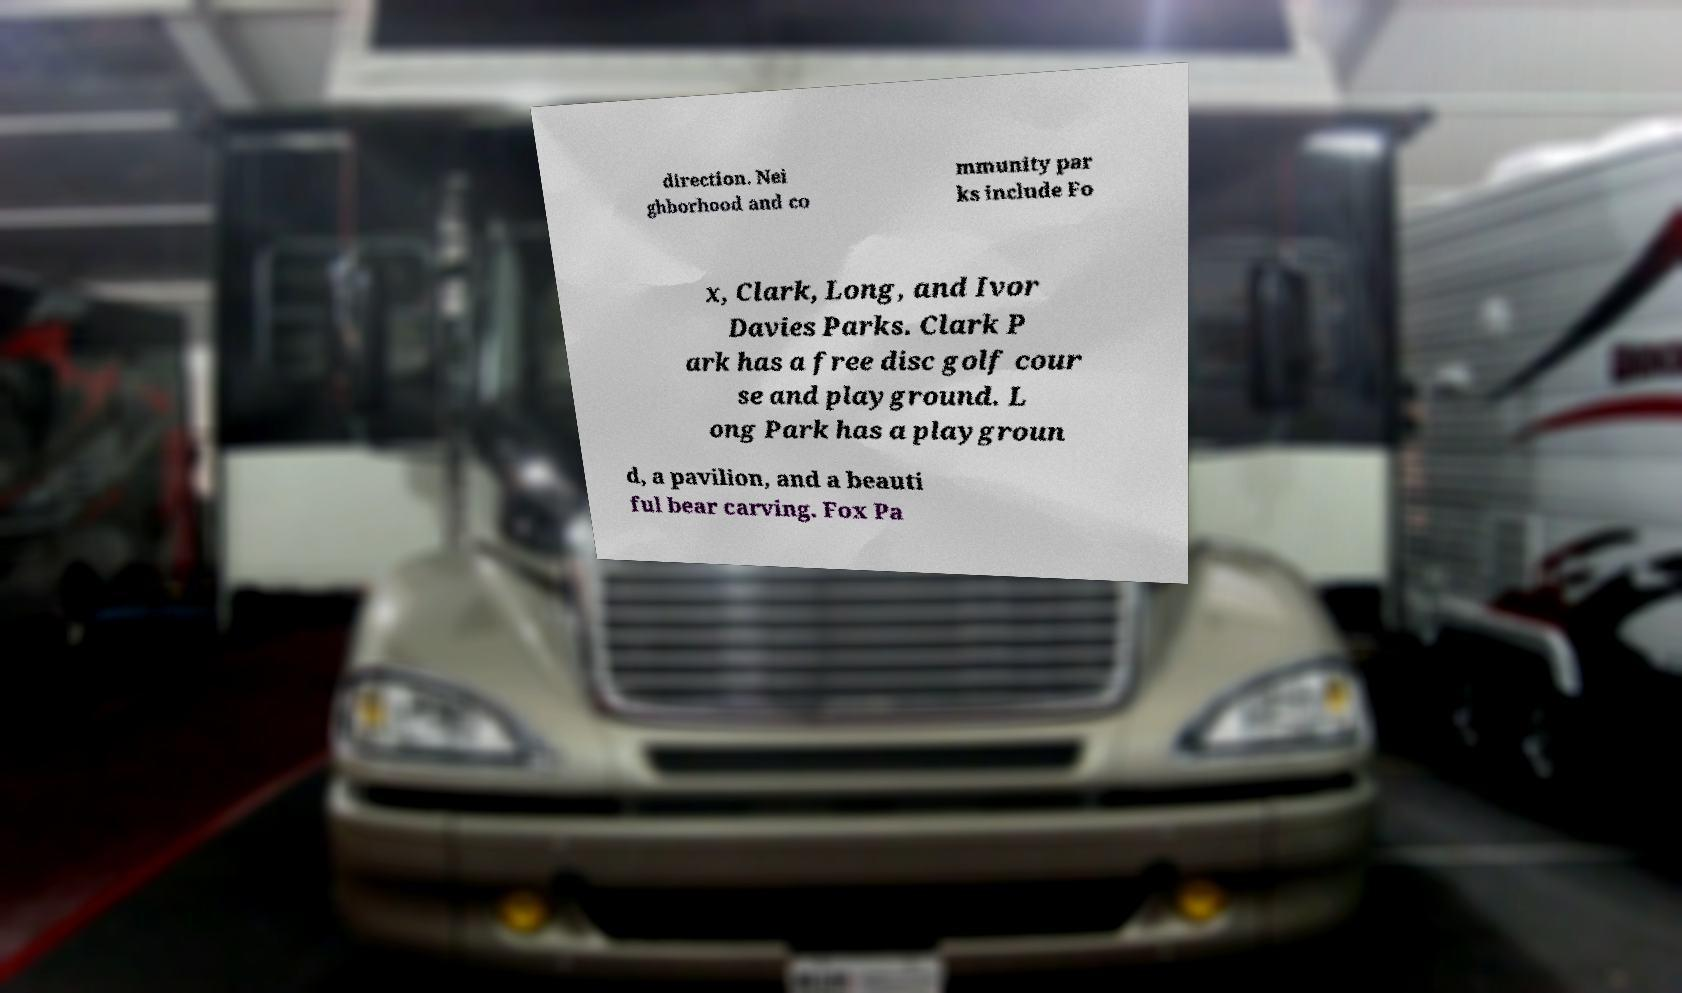For documentation purposes, I need the text within this image transcribed. Could you provide that? direction. Nei ghborhood and co mmunity par ks include Fo x, Clark, Long, and Ivor Davies Parks. Clark P ark has a free disc golf cour se and playground. L ong Park has a playgroun d, a pavilion, and a beauti ful bear carving. Fox Pa 